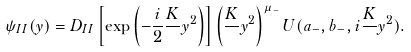<formula> <loc_0><loc_0><loc_500><loc_500>\psi _ { I I } ( y ) = D _ { I I } \left [ \exp \left ( - \frac { i } { 2 } \frac { K } { } y ^ { 2 } \right ) \right ] \left ( \frac { K } { } y ^ { 2 } \right ) ^ { \mu _ { - } } U ( a _ { - } , b _ { - } , i \frac { K } { } y ^ { 2 } ) .</formula> 